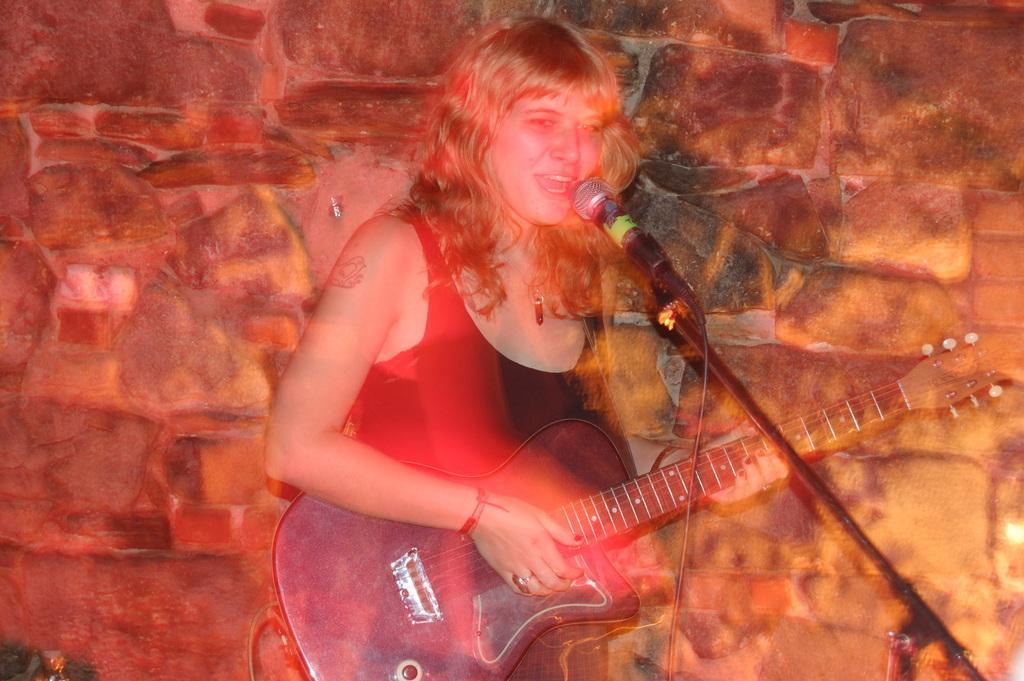Can you describe this image briefly? In this image i can see a woman playing a guitar and singing in front of a microphone, at the back ground there is a wall. 